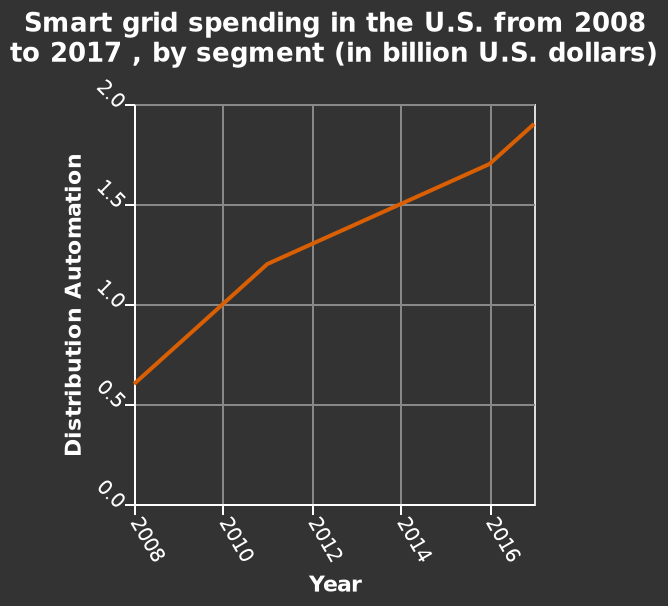<image>
What does the x-axis plot in the line chart?  The x-axis plots "Year". What is the range of years covered in the line chart? The line chart covers the years from 2008 to 2017. please summary the statistics and relations of the chart There has been a steep growth in spending on the smart grid between 2008 and 2017 in the U.S. Growth did decline slightly between 2011 and 2016, but has now returned to its previous rate. 